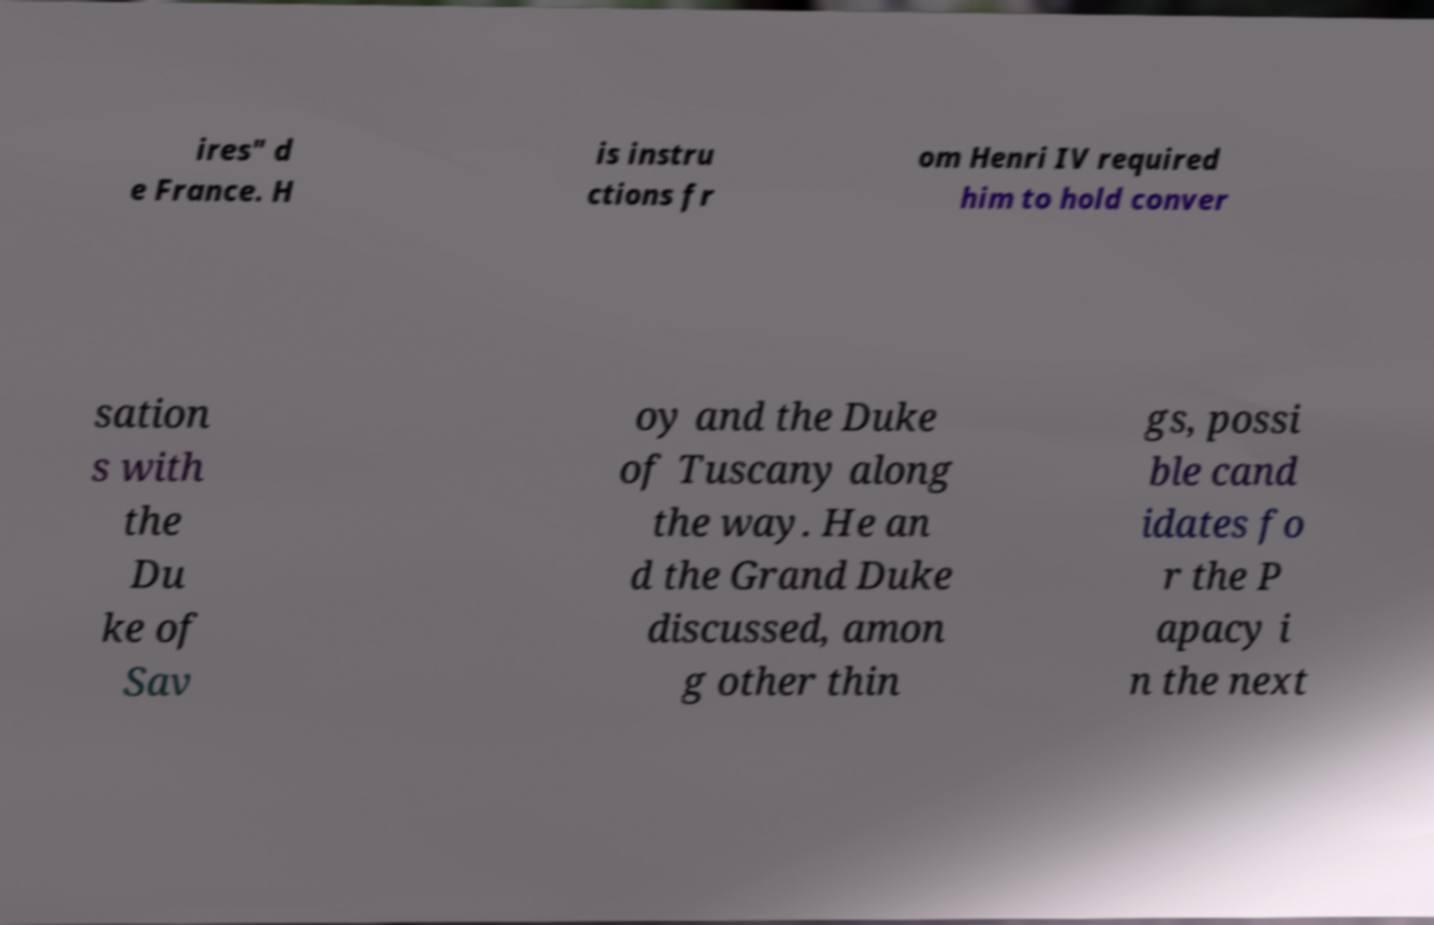What messages or text are displayed in this image? I need them in a readable, typed format. ires" d e France. H is instru ctions fr om Henri IV required him to hold conver sation s with the Du ke of Sav oy and the Duke of Tuscany along the way. He an d the Grand Duke discussed, amon g other thin gs, possi ble cand idates fo r the P apacy i n the next 